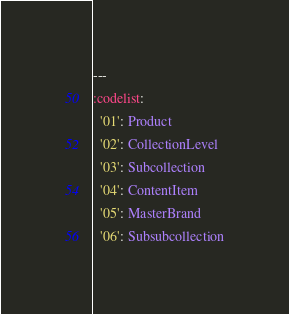Convert code to text. <code><loc_0><loc_0><loc_500><loc_500><_YAML_>---
:codelist:
  '01': Product
  '02': CollectionLevel
  '03': Subcollection
  '04': ContentItem
  '05': MasterBrand
  '06': Subsubcollection
</code> 